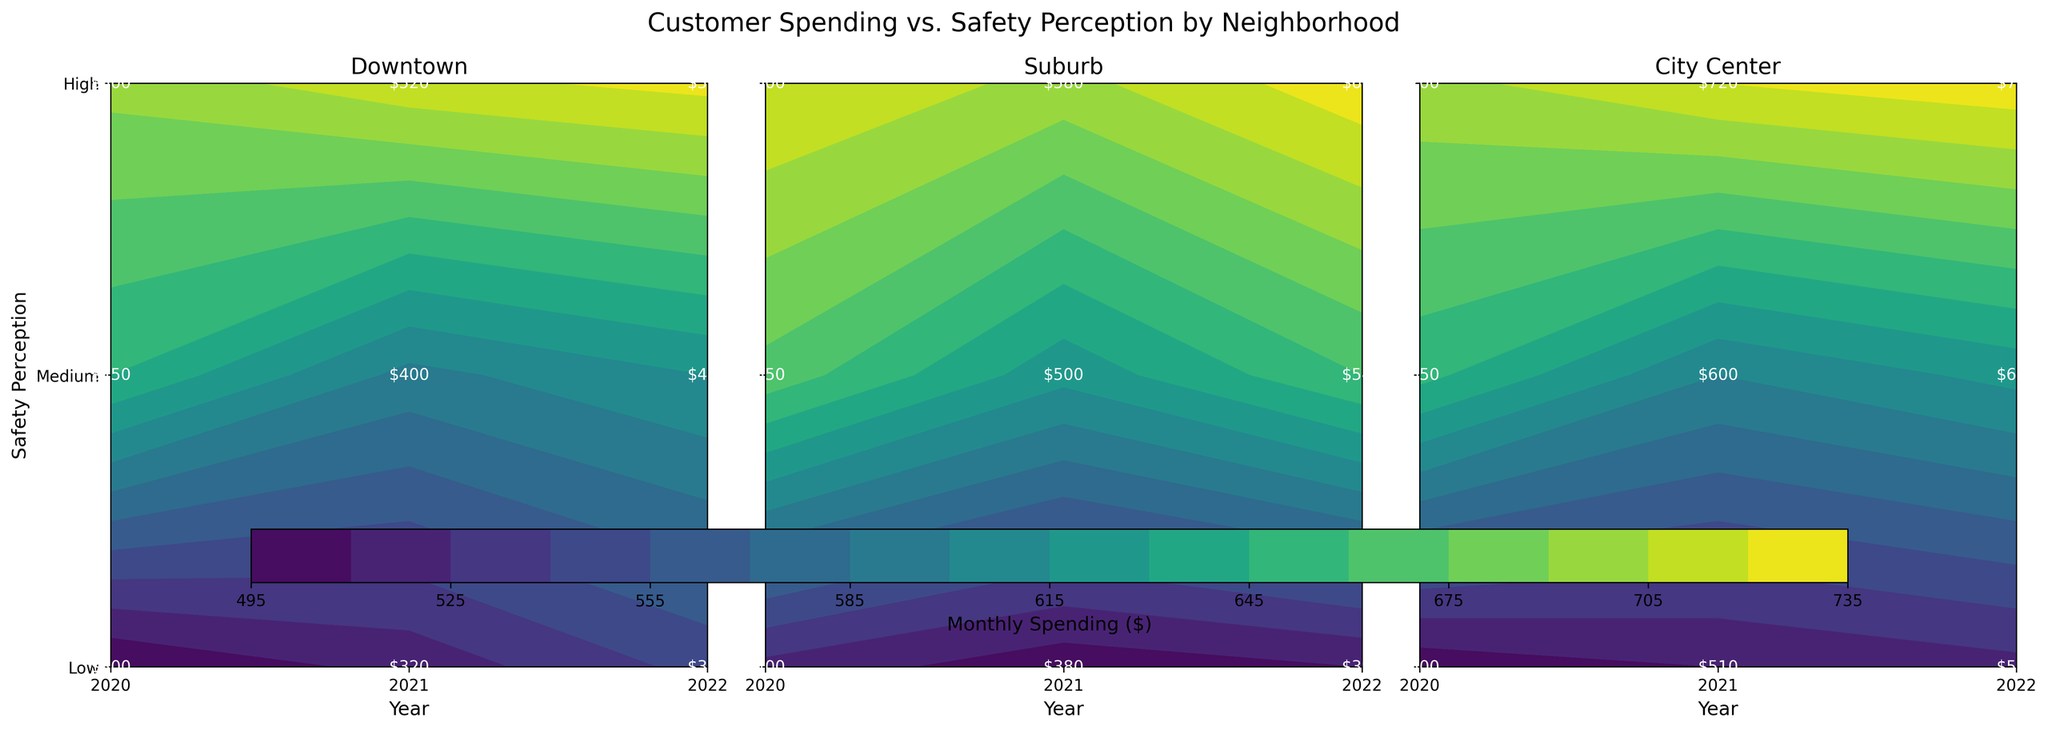What neighborhood has the highest customer spending? By inspecting the figure, the highest spending contour value is darkest in the "City Center" neighborhood for all years.
Answer: City Center How does customer spending in Downtown compare between high and low safety perceptions in 2022? For "Downtown" in 2022, cross-referencing the contour levels for 'High' safety shows around 530 dollars, whereas 'Low' safety shows around 350 dollars.
Answer: Higher in high safety perception What is the trend in customer spending over the years in the Suburb neighborhood for medium safety perception? In the "Suburb" neighborhood and "Medium" safety perception, the figures show spending increases from around 550 dollars in 2020 to 540 dollars in 2022.
Answer: Decreasing trend Which year had the lowest customer spending in the City Center for low safety perception? The chart for "City Center" shows values at the lowest contour levels for 'Low' safety perception in 2020 (~500 dollars).
Answer: 2020 Is there a correlation between safety perception and customer spending in the Downtown neighborhood over the years? By examining the contours for "Downtown," customer spending increases as safety perception increases for all years.
Answer: Positive correlation How does the spending change from 2021 to 2022 in the Suburb neighborhood for high safety perception? In the "Suburb" neighborhood, spending changes from ~580 dollars in 2021 to ~610 dollars in 2022 for 'High' safety perception.
Answer: Increased Which safety perception level in any neighborhood shows the greatest spending increase over the three years? By examining all subplots, the greatest increase is from 'Medium' safety perception in the "City Center" neighborhood going from around 650 dollars in 2020 to around 680 dollars in 2022.
Answer: Medium safety in City Center Which neighborhood shows the least customer spending variability for any safety perception across all years? The "Downtown" neighborhood shows the least variability for 'Low' safety, ranging closely around 320 dollars to 350 dollars across all years.
Answer: Downtown (Low safety) For which safety level does the Suburb neighborhood show the smallest year-to-year variation? In the "Suburb" neighborhood, 'Low' safety shows very minimal variations, ranging from around 400 dollars in 2020 to 390 dollars in 2022.
Answer: Low safety In 2022, which safety perception level has the closest spending values across all neighborhoods? Observing 2022 data, the 'Low' safety perception levels for all neighborhoods have spending values close to around 350 to 390 dollars.
Answer: Low safety 